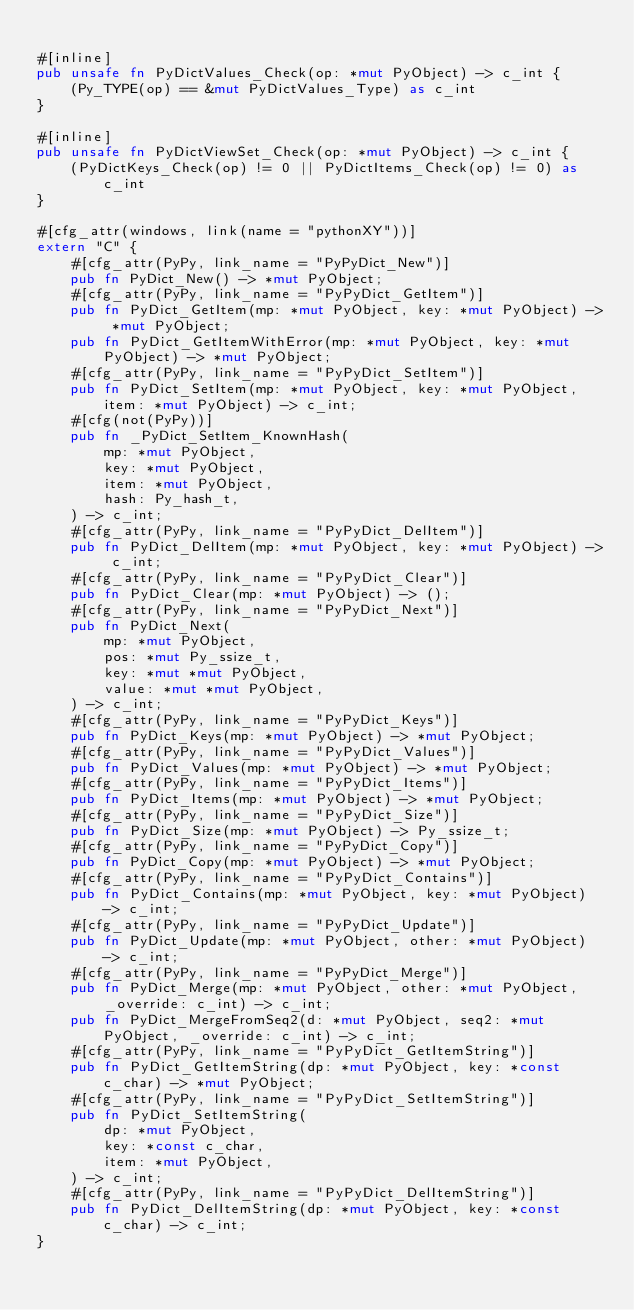<code> <loc_0><loc_0><loc_500><loc_500><_Rust_>
#[inline]
pub unsafe fn PyDictValues_Check(op: *mut PyObject) -> c_int {
    (Py_TYPE(op) == &mut PyDictValues_Type) as c_int
}

#[inline]
pub unsafe fn PyDictViewSet_Check(op: *mut PyObject) -> c_int {
    (PyDictKeys_Check(op) != 0 || PyDictItems_Check(op) != 0) as c_int
}

#[cfg_attr(windows, link(name = "pythonXY"))]
extern "C" {
    #[cfg_attr(PyPy, link_name = "PyPyDict_New")]
    pub fn PyDict_New() -> *mut PyObject;
    #[cfg_attr(PyPy, link_name = "PyPyDict_GetItem")]
    pub fn PyDict_GetItem(mp: *mut PyObject, key: *mut PyObject) -> *mut PyObject;
    pub fn PyDict_GetItemWithError(mp: *mut PyObject, key: *mut PyObject) -> *mut PyObject;
    #[cfg_attr(PyPy, link_name = "PyPyDict_SetItem")]
    pub fn PyDict_SetItem(mp: *mut PyObject, key: *mut PyObject, item: *mut PyObject) -> c_int;
    #[cfg(not(PyPy))]
    pub fn _PyDict_SetItem_KnownHash(
        mp: *mut PyObject,
        key: *mut PyObject,
        item: *mut PyObject,
        hash: Py_hash_t,
    ) -> c_int;
    #[cfg_attr(PyPy, link_name = "PyPyDict_DelItem")]
    pub fn PyDict_DelItem(mp: *mut PyObject, key: *mut PyObject) -> c_int;
    #[cfg_attr(PyPy, link_name = "PyPyDict_Clear")]
    pub fn PyDict_Clear(mp: *mut PyObject) -> ();
    #[cfg_attr(PyPy, link_name = "PyPyDict_Next")]
    pub fn PyDict_Next(
        mp: *mut PyObject,
        pos: *mut Py_ssize_t,
        key: *mut *mut PyObject,
        value: *mut *mut PyObject,
    ) -> c_int;
    #[cfg_attr(PyPy, link_name = "PyPyDict_Keys")]
    pub fn PyDict_Keys(mp: *mut PyObject) -> *mut PyObject;
    #[cfg_attr(PyPy, link_name = "PyPyDict_Values")]
    pub fn PyDict_Values(mp: *mut PyObject) -> *mut PyObject;
    #[cfg_attr(PyPy, link_name = "PyPyDict_Items")]
    pub fn PyDict_Items(mp: *mut PyObject) -> *mut PyObject;
    #[cfg_attr(PyPy, link_name = "PyPyDict_Size")]
    pub fn PyDict_Size(mp: *mut PyObject) -> Py_ssize_t;
    #[cfg_attr(PyPy, link_name = "PyPyDict_Copy")]
    pub fn PyDict_Copy(mp: *mut PyObject) -> *mut PyObject;
    #[cfg_attr(PyPy, link_name = "PyPyDict_Contains")]
    pub fn PyDict_Contains(mp: *mut PyObject, key: *mut PyObject) -> c_int;
    #[cfg_attr(PyPy, link_name = "PyPyDict_Update")]
    pub fn PyDict_Update(mp: *mut PyObject, other: *mut PyObject) -> c_int;
    #[cfg_attr(PyPy, link_name = "PyPyDict_Merge")]
    pub fn PyDict_Merge(mp: *mut PyObject, other: *mut PyObject, _override: c_int) -> c_int;
    pub fn PyDict_MergeFromSeq2(d: *mut PyObject, seq2: *mut PyObject, _override: c_int) -> c_int;
    #[cfg_attr(PyPy, link_name = "PyPyDict_GetItemString")]
    pub fn PyDict_GetItemString(dp: *mut PyObject, key: *const c_char) -> *mut PyObject;
    #[cfg_attr(PyPy, link_name = "PyPyDict_SetItemString")]
    pub fn PyDict_SetItemString(
        dp: *mut PyObject,
        key: *const c_char,
        item: *mut PyObject,
    ) -> c_int;
    #[cfg_attr(PyPy, link_name = "PyPyDict_DelItemString")]
    pub fn PyDict_DelItemString(dp: *mut PyObject, key: *const c_char) -> c_int;
}
</code> 